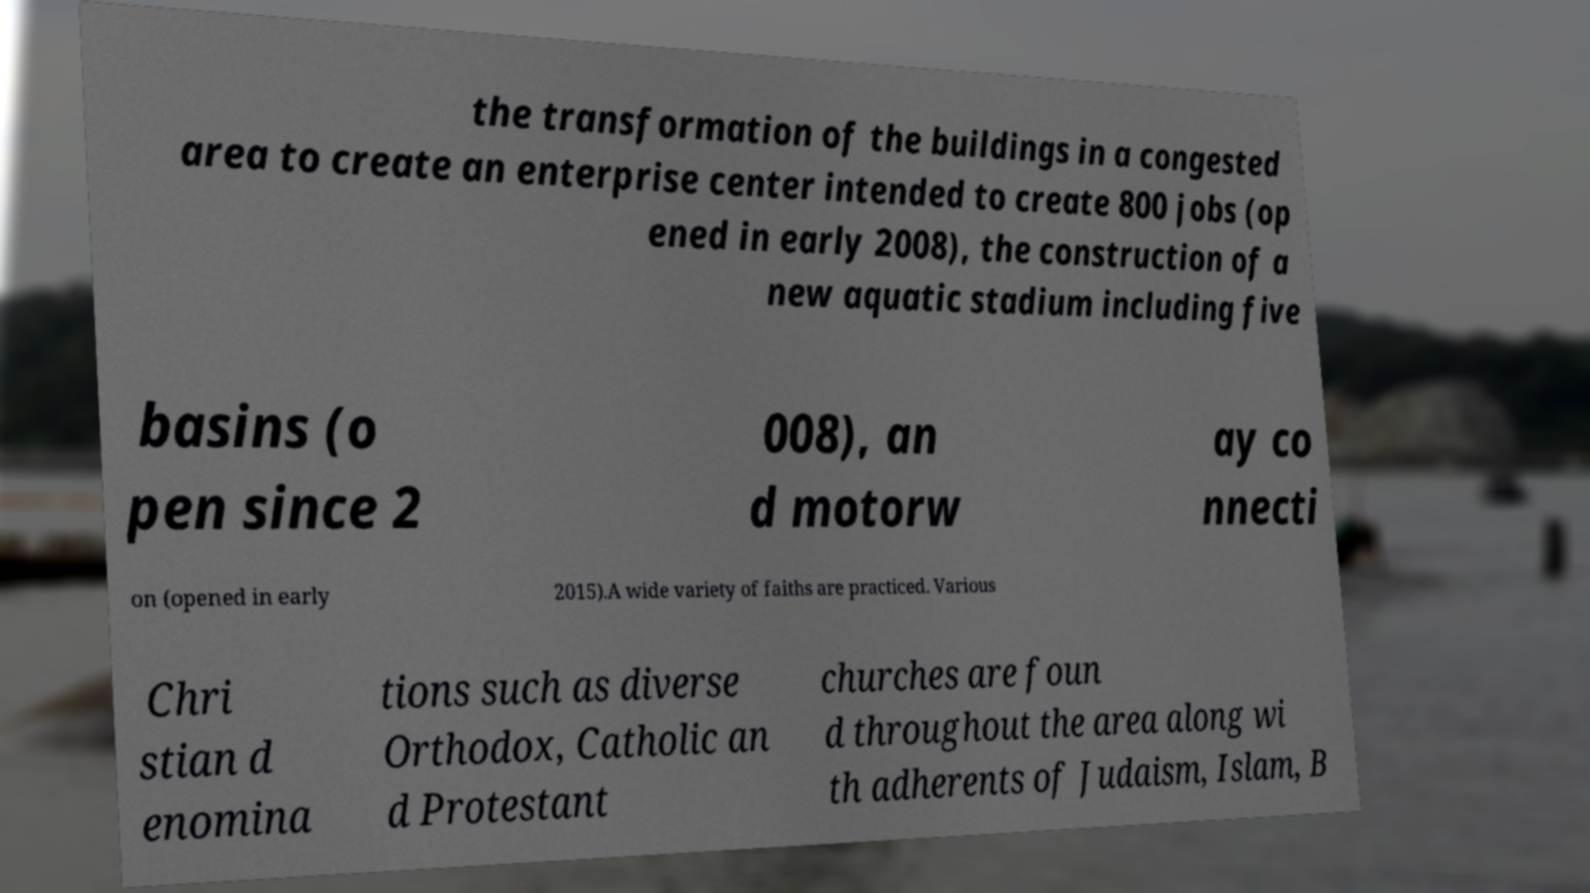Can you read and provide the text displayed in the image?This photo seems to have some interesting text. Can you extract and type it out for me? the transformation of the buildings in a congested area to create an enterprise center intended to create 800 jobs (op ened in early 2008), the construction of a new aquatic stadium including five basins (o pen since 2 008), an d motorw ay co nnecti on (opened in early 2015).A wide variety of faiths are practiced. Various Chri stian d enomina tions such as diverse Orthodox, Catholic an d Protestant churches are foun d throughout the area along wi th adherents of Judaism, Islam, B 